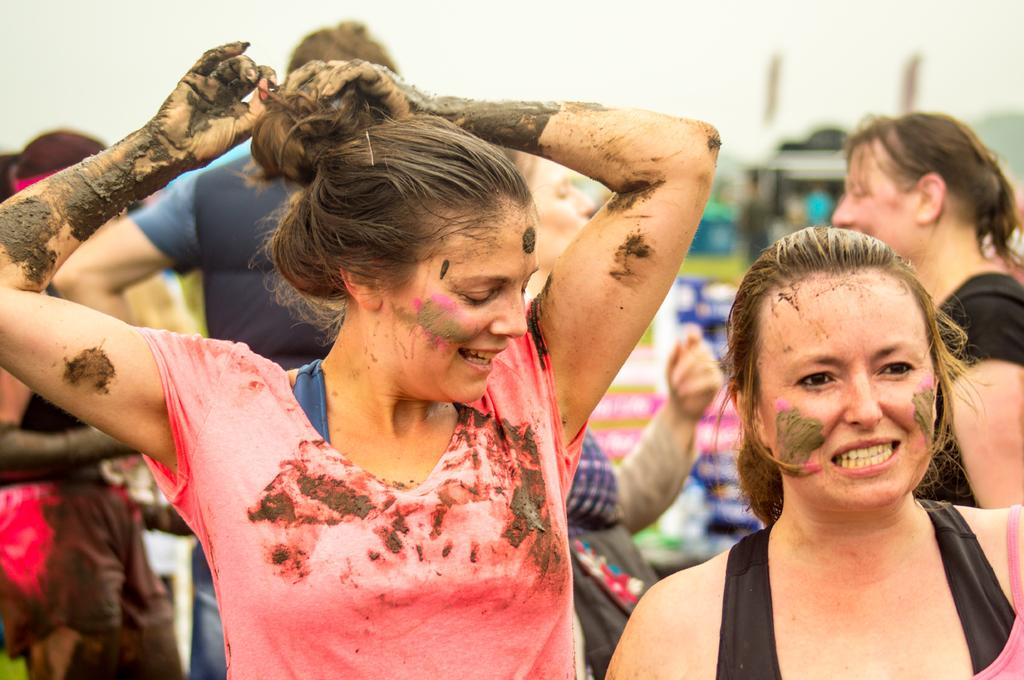What is the lady in the center of the image doing? The lady in the center of the image has mud in her hands. Can you describe the lady to the right side of the image? There is another lady to the right side of the image. What else can be seen in the background of the image? People and the sky are visible in the background of the image. What type of bun is the lady in the center of the image holding? There is no bun present in the image; the lady has mud in her hands. Can you describe the cattle in the image? There are no cattle present in the image. 